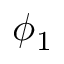Convert formula to latex. <formula><loc_0><loc_0><loc_500><loc_500>\phi _ { 1 }</formula> 